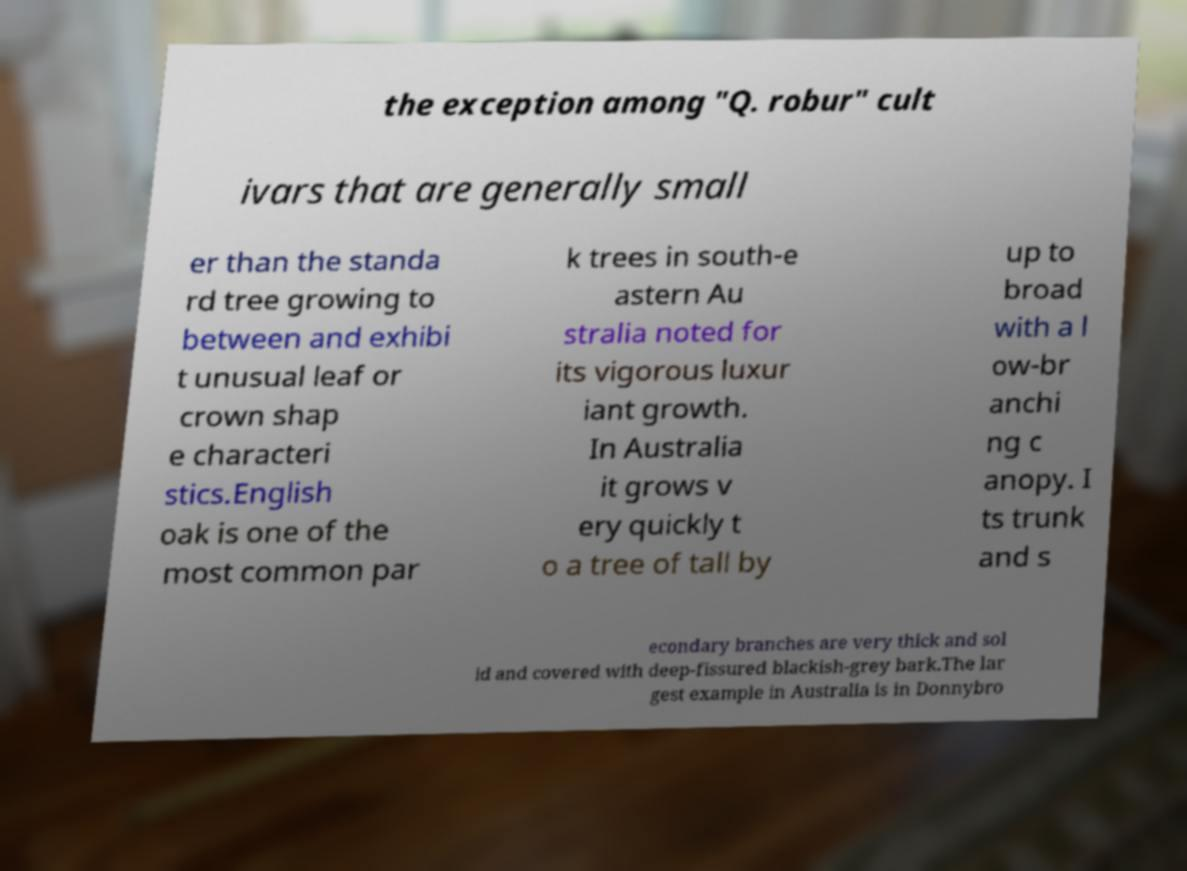There's text embedded in this image that I need extracted. Can you transcribe it verbatim? the exception among "Q. robur" cult ivars that are generally small er than the standa rd tree growing to between and exhibi t unusual leaf or crown shap e characteri stics.English oak is one of the most common par k trees in south-e astern Au stralia noted for its vigorous luxur iant growth. In Australia it grows v ery quickly t o a tree of tall by up to broad with a l ow-br anchi ng c anopy. I ts trunk and s econdary branches are very thick and sol id and covered with deep-fissured blackish-grey bark.The lar gest example in Australia is in Donnybro 